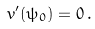Convert formula to latex. <formula><loc_0><loc_0><loc_500><loc_500>v ^ { \prime } ( \psi _ { 0 } ) = 0 \, .</formula> 